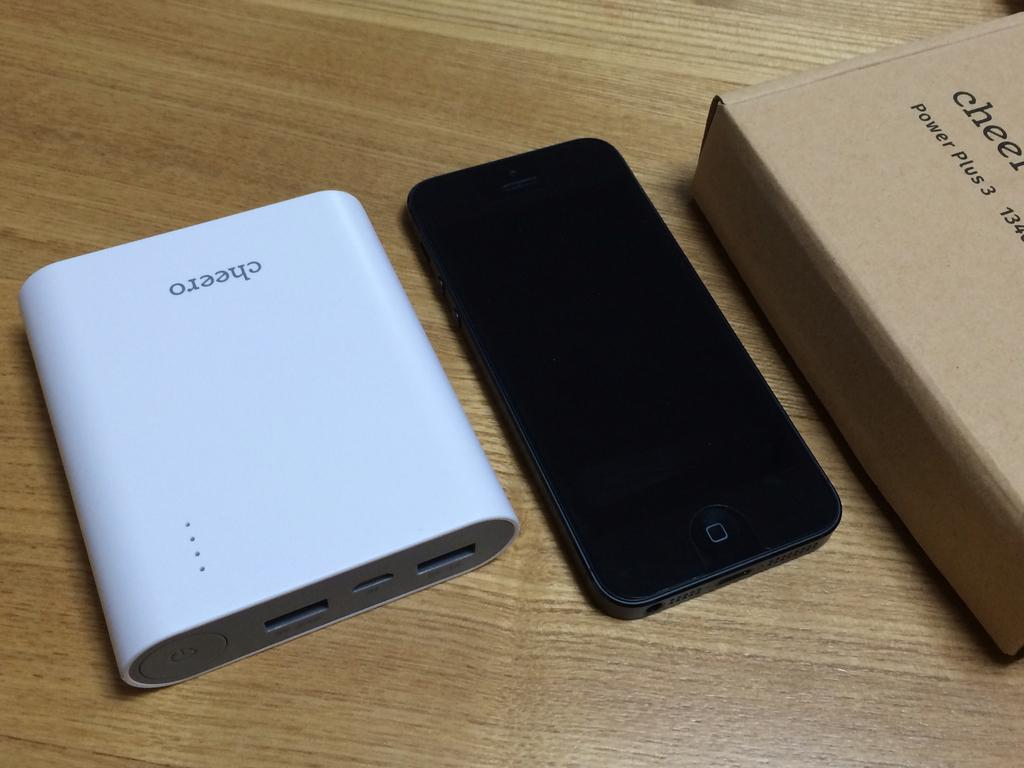<image>
Summarize the visual content of the image. A phone sits by a device with the word Cheero upside down on it. 